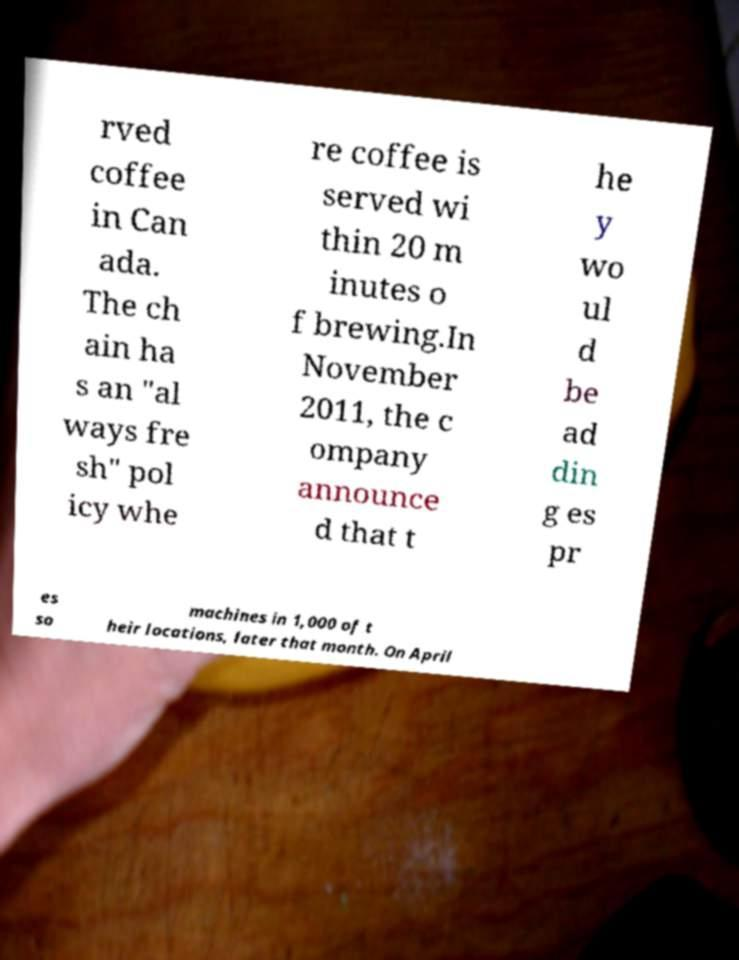Could you assist in decoding the text presented in this image and type it out clearly? rved coffee in Can ada. The ch ain ha s an "al ways fre sh" pol icy whe re coffee is served wi thin 20 m inutes o f brewing.In November 2011, the c ompany announce d that t he y wo ul d be ad din g es pr es so machines in 1,000 of t heir locations, later that month. On April 